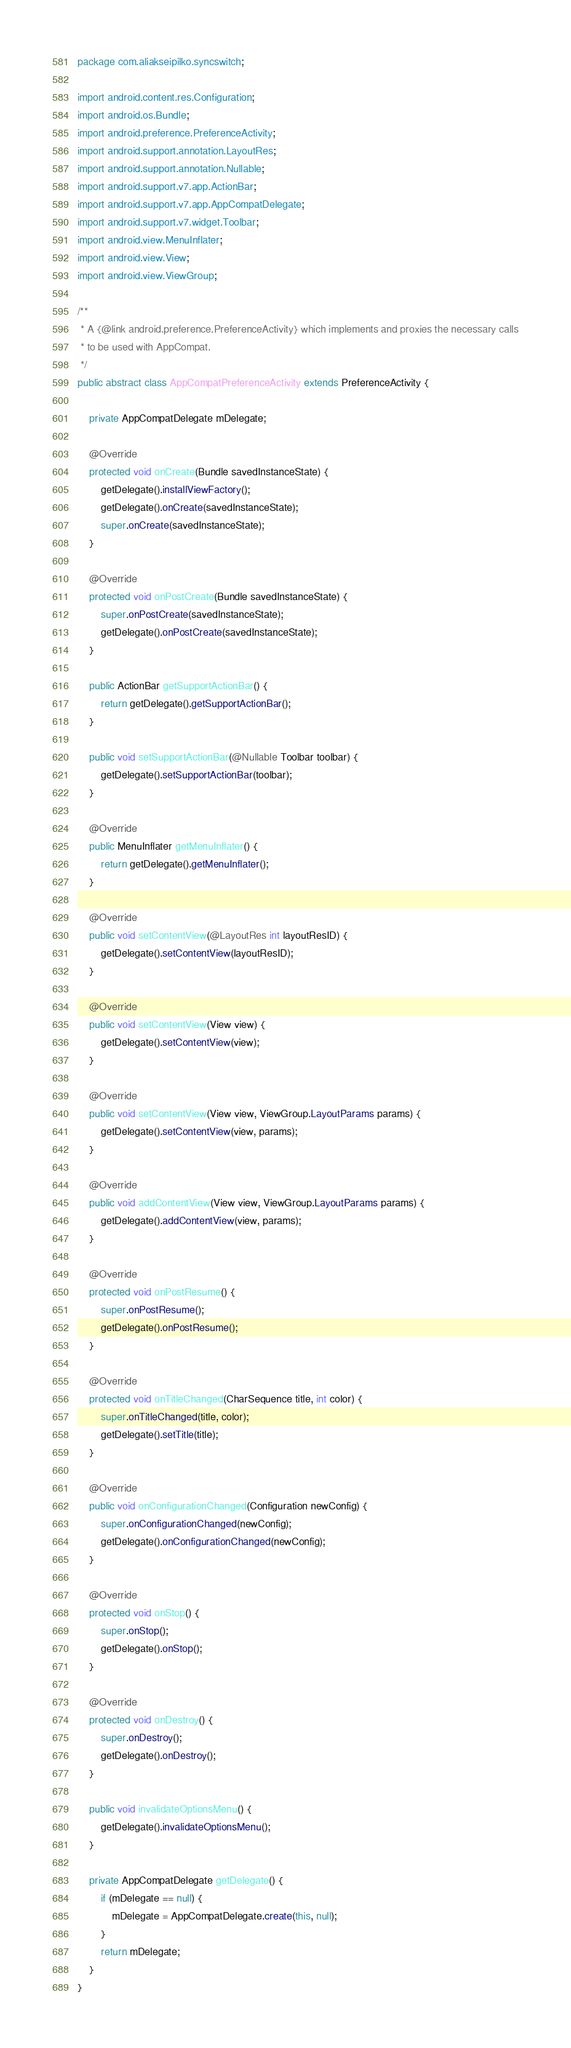<code> <loc_0><loc_0><loc_500><loc_500><_Java_>package com.aliakseipilko.syncswitch;

import android.content.res.Configuration;
import android.os.Bundle;
import android.preference.PreferenceActivity;
import android.support.annotation.LayoutRes;
import android.support.annotation.Nullable;
import android.support.v7.app.ActionBar;
import android.support.v7.app.AppCompatDelegate;
import android.support.v7.widget.Toolbar;
import android.view.MenuInflater;
import android.view.View;
import android.view.ViewGroup;

/**
 * A {@link android.preference.PreferenceActivity} which implements and proxies the necessary calls
 * to be used with AppCompat.
 */
public abstract class AppCompatPreferenceActivity extends PreferenceActivity {

    private AppCompatDelegate mDelegate;

    @Override
    protected void onCreate(Bundle savedInstanceState) {
        getDelegate().installViewFactory();
        getDelegate().onCreate(savedInstanceState);
        super.onCreate(savedInstanceState);
    }

    @Override
    protected void onPostCreate(Bundle savedInstanceState) {
        super.onPostCreate(savedInstanceState);
        getDelegate().onPostCreate(savedInstanceState);
    }

    public ActionBar getSupportActionBar() {
        return getDelegate().getSupportActionBar();
    }

    public void setSupportActionBar(@Nullable Toolbar toolbar) {
        getDelegate().setSupportActionBar(toolbar);
    }

    @Override
    public MenuInflater getMenuInflater() {
        return getDelegate().getMenuInflater();
    }

    @Override
    public void setContentView(@LayoutRes int layoutResID) {
        getDelegate().setContentView(layoutResID);
    }

    @Override
    public void setContentView(View view) {
        getDelegate().setContentView(view);
    }

    @Override
    public void setContentView(View view, ViewGroup.LayoutParams params) {
        getDelegate().setContentView(view, params);
    }

    @Override
    public void addContentView(View view, ViewGroup.LayoutParams params) {
        getDelegate().addContentView(view, params);
    }

    @Override
    protected void onPostResume() {
        super.onPostResume();
        getDelegate().onPostResume();
    }

    @Override
    protected void onTitleChanged(CharSequence title, int color) {
        super.onTitleChanged(title, color);
        getDelegate().setTitle(title);
    }

    @Override
    public void onConfigurationChanged(Configuration newConfig) {
        super.onConfigurationChanged(newConfig);
        getDelegate().onConfigurationChanged(newConfig);
    }

    @Override
    protected void onStop() {
        super.onStop();
        getDelegate().onStop();
    }

    @Override
    protected void onDestroy() {
        super.onDestroy();
        getDelegate().onDestroy();
    }

    public void invalidateOptionsMenu() {
        getDelegate().invalidateOptionsMenu();
    }

    private AppCompatDelegate getDelegate() {
        if (mDelegate == null) {
            mDelegate = AppCompatDelegate.create(this, null);
        }
        return mDelegate;
    }
}
</code> 